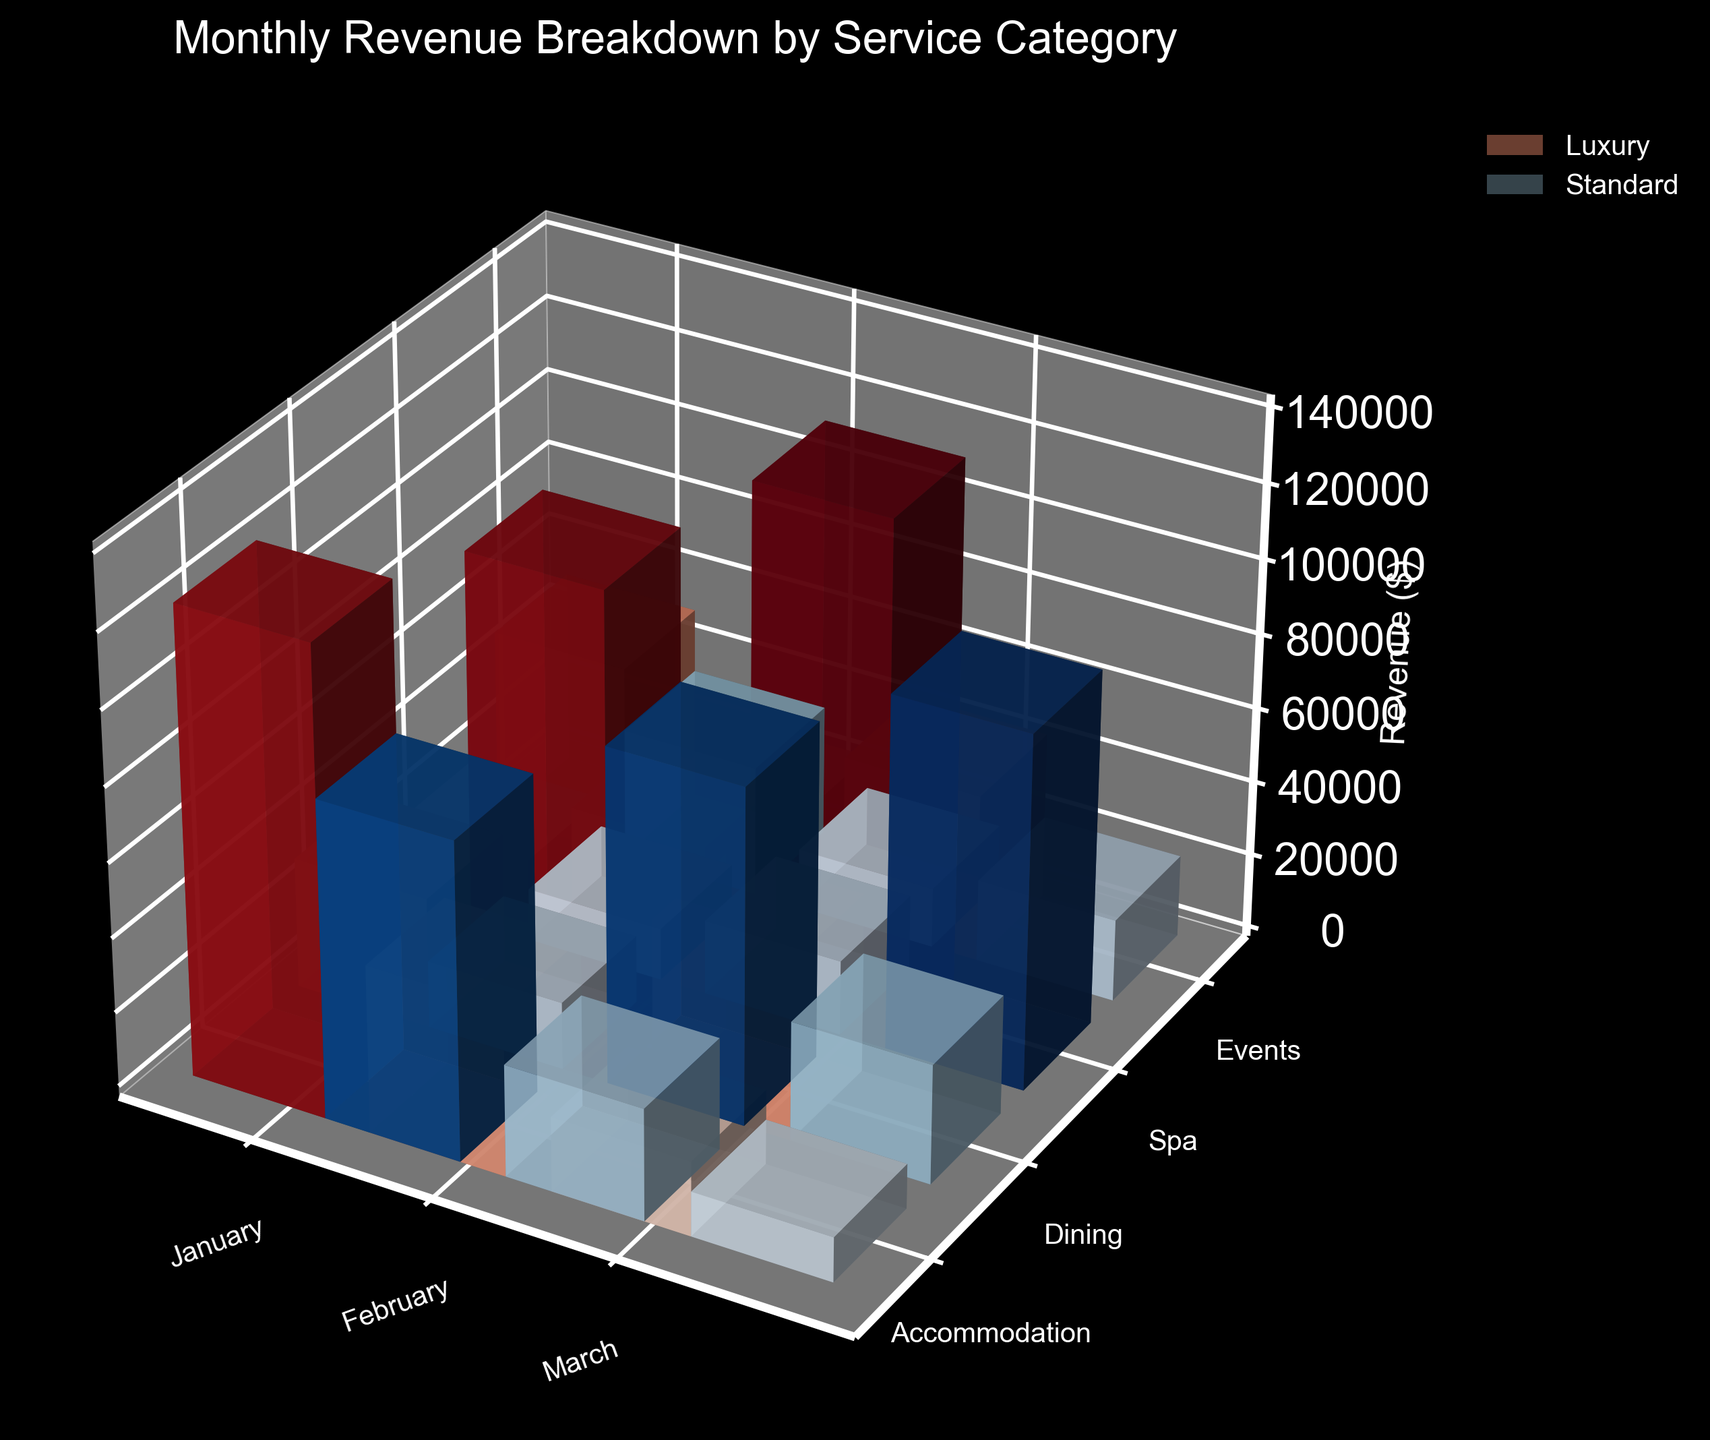What is the title of the plot? Look at the text at the top of the plot, it usually describes what the plot is about.
Answer: Monthly Revenue Breakdown by Service Category Which month has the highest total revenue for luxury offerings? To determine this, look at the height of all luxury bars for each month and find the month with the tallest combined height. March has the highest total, with the sums of accommodation, dining, spa, and events being the tallest.
Answer: March In January, what is the revenue for standard dining? Locate the bar for January under the dining category and check the height of the bar related to standard offerings.
Answer: $30,000 What is the color scheme used to distinguish luxury and standard offerings? Examine the color of the bars to identify the distinction. The luxury bars are in shades of red and the standard bars are in shades of blue.
Answer: Red for luxury, blue for standard Which service category has the smallest difference in revenue between luxury and standard offerings in February? Find the bars for all categories in February and calculate the revenue difference between luxury and standard for each category; pick the smallest difference. For February: Accommodation (130,000 - 90,000 = 40,000), Dining (48,000 - 32,000 = 16,000), Spa (22,000 - 14,000 = 8,000), and Events (40,000 - 20,000 = 20,000).
Answer: Spa How has the revenue for luxury accommodation changed from January to March? Compare the height of the luxury accommodation bars for January, February, and March to see the change in revenue. January = 125,000, February = 130,000, March = 140,000. The revenue has increased each month.
Answer: Increased Which month shows the lowest revenue for standard spa services? Identify the standard spa bars for all months and compare their heights to find the shortest one.
Answer: January What is the combined revenue for luxury and standard events in March? Add the height of the luxury and standard events bars in March. Luxury = $45,000, Standard = $22,000. Combined revenue = 45,000 + 22,000.
Answer: $67,000 Does the revenue of luxury dining in March exceed the revenue of standard accommodation in January? Compare the height of the luxury dining bar in March with the standard accommodation bar in January. Luxury Dining (March) = $52,000, Standard Accommodation (January) = $85,000. 52,000 < 85,000.
Answer: No 